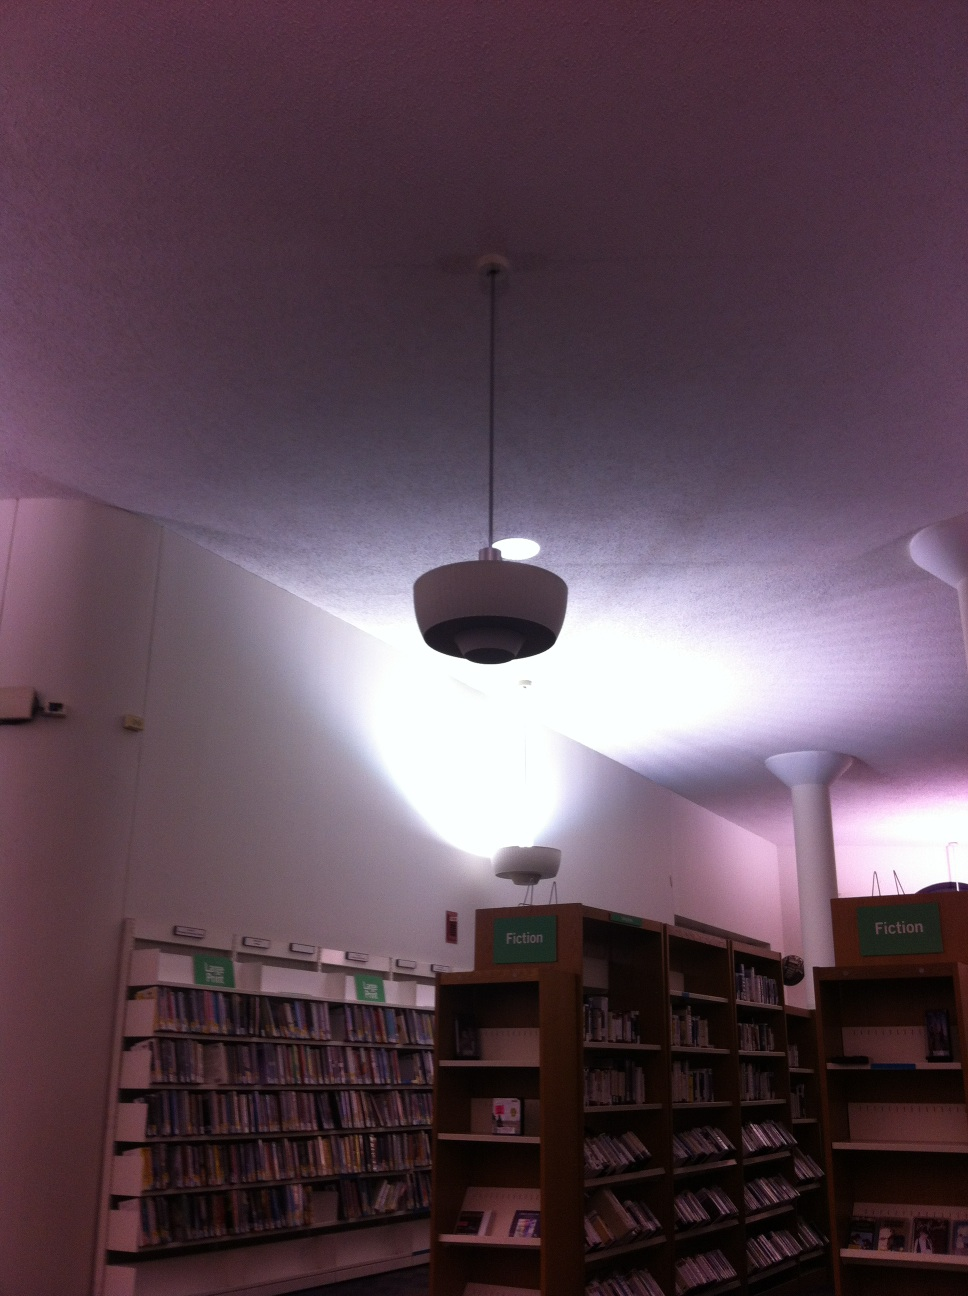This place looks interesting, can you tell me more about it? Absolutely! This library is a serene haven for book lovers. Apart from the extensive collection of fiction books, it also offers a variety of other resources, including non-fiction, reference materials, and multimedia options. The library often hosts community events such as book readings and discussions, making it a vibrant hub of intellectual and cultural activities. 